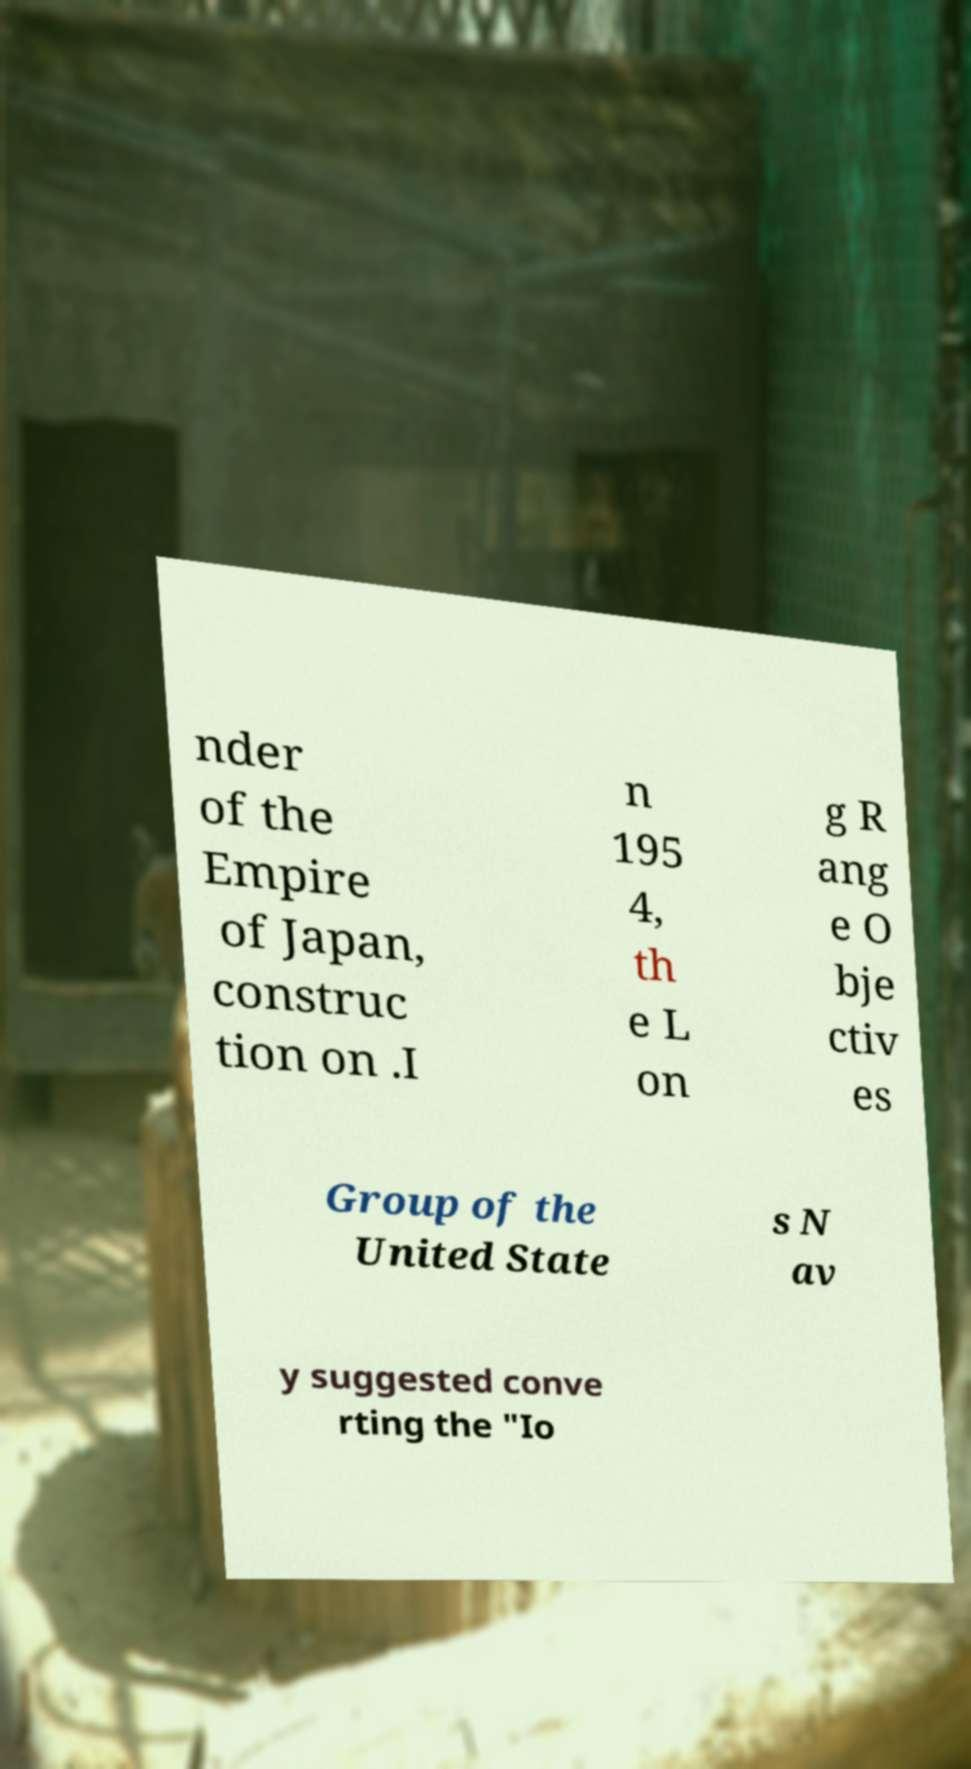Can you accurately transcribe the text from the provided image for me? nder of the Empire of Japan, construc tion on .I n 195 4, th e L on g R ang e O bje ctiv es Group of the United State s N av y suggested conve rting the "Io 